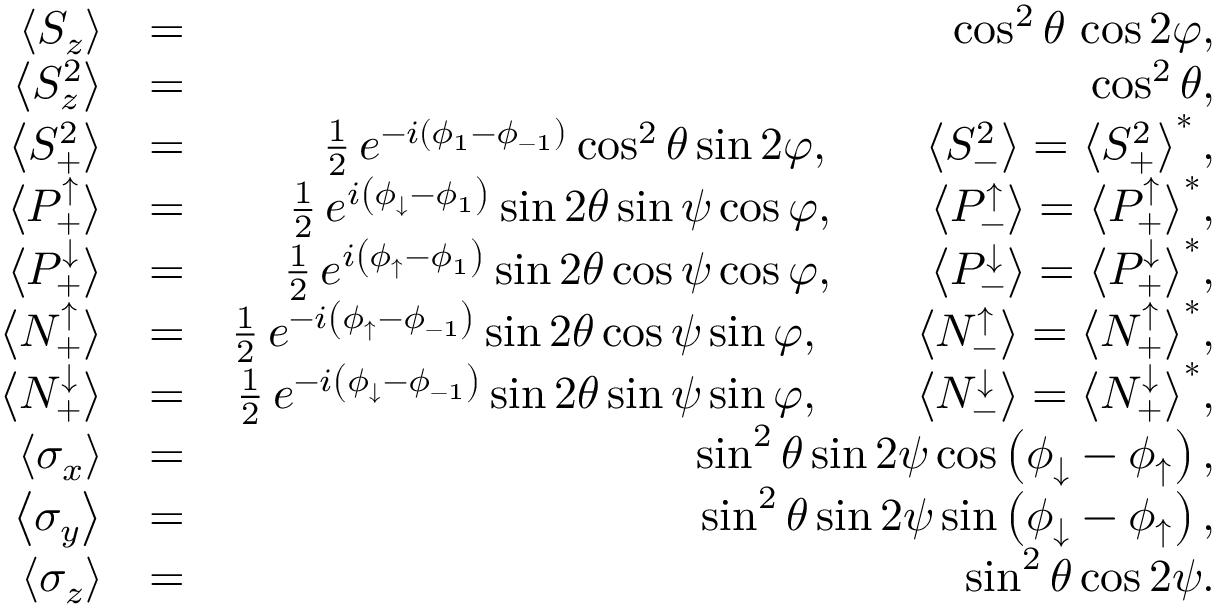<formula> <loc_0><loc_0><loc_500><loc_500>\begin{array} { r l r } { \left \langle S _ { z } \right \rangle } & { = } & { \cos ^ { 2 } \theta \, \cos 2 \varphi , } \\ { \left \langle S _ { z } ^ { 2 } \right \rangle } & { = } & { \cos ^ { 2 } \theta , } \\ { \left \langle S _ { + } ^ { 2 } \right \rangle } & { = } & { \frac { 1 } { 2 } \, e ^ { - i \left ( \phi _ { 1 } - \phi _ { - 1 } \right ) } \cos ^ { 2 } \theta \sin 2 \varphi , \quad \left \langle S _ { - } ^ { 2 } \right \rangle = \left \langle S _ { + } ^ { 2 } \right \rangle ^ { * } , } \\ { \left \langle P _ { + } ^ { \uparrow } \right \rangle } & { = } & { \frac { 1 } { 2 } \, e ^ { i \left ( \phi _ { \downarrow } - \phi _ { 1 } \right ) } \sin 2 \theta \sin \psi \cos \varphi , \quad \left \langle P _ { - } ^ { \uparrow } \right \rangle = \left \langle P _ { + } ^ { \uparrow } \right \rangle ^ { * } , } \\ { \left \langle P _ { + } ^ { \downarrow } \right \rangle } & { = } & { \frac { 1 } { 2 } \, e ^ { i \left ( \phi _ { \uparrow } - \phi _ { 1 } \right ) } \sin 2 \theta \cos \psi \cos \varphi , \quad \left \langle P _ { - } ^ { \downarrow } \right \rangle = \left \langle P _ { + } ^ { \downarrow } \right \rangle ^ { * } , } \\ { \left \langle N _ { + } ^ { \uparrow } \right \rangle } & { = } & { \frac { 1 } { 2 } \, e ^ { - i \left ( \phi _ { \uparrow } - \phi _ { - 1 } \right ) } \sin 2 \theta \cos \psi \sin \varphi , \quad \left \langle N _ { - } ^ { \uparrow } \right \rangle = \left \langle N _ { + } ^ { \uparrow } \right \rangle ^ { * } , } \\ { \left \langle N _ { + } ^ { \downarrow } \right \rangle } & { = } & { \frac { 1 } { 2 } \, e ^ { - i \left ( \phi _ { \downarrow } - \phi _ { - 1 } \right ) } \sin 2 \theta \sin \psi \sin \varphi , \quad \left \langle N _ { - } ^ { \downarrow } \right \rangle = \left \langle N _ { + } ^ { \downarrow } \right \rangle ^ { * } , } \\ { \left \langle \sigma _ { x } \right \rangle } & { = } & { \sin ^ { 2 } \theta \sin 2 \psi \cos \left ( \phi _ { \downarrow } - \phi _ { \uparrow } \right ) , } \\ { \left \langle \sigma _ { y } \right \rangle } & { = } & { \sin ^ { 2 } \theta \sin 2 \psi \sin \left ( \phi _ { \downarrow } - \phi _ { \uparrow } \right ) , } \\ { \left \langle \sigma _ { z } \right \rangle } & { = } & { \sin ^ { 2 } \theta \cos 2 \psi . } \end{array}</formula> 